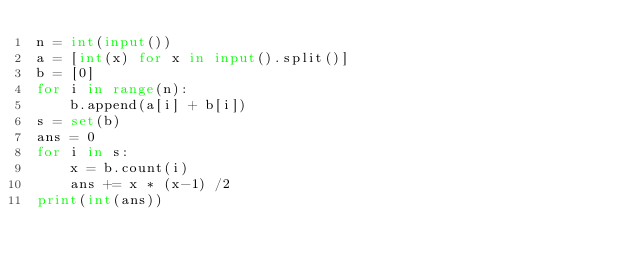<code> <loc_0><loc_0><loc_500><loc_500><_Python_>n = int(input())
a = [int(x) for x in input().split()]
b = [0]
for i in range(n):
    b.append(a[i] + b[i])
s = set(b)
ans = 0
for i in s:
    x = b.count(i)
    ans += x * (x-1) /2
print(int(ans))</code> 